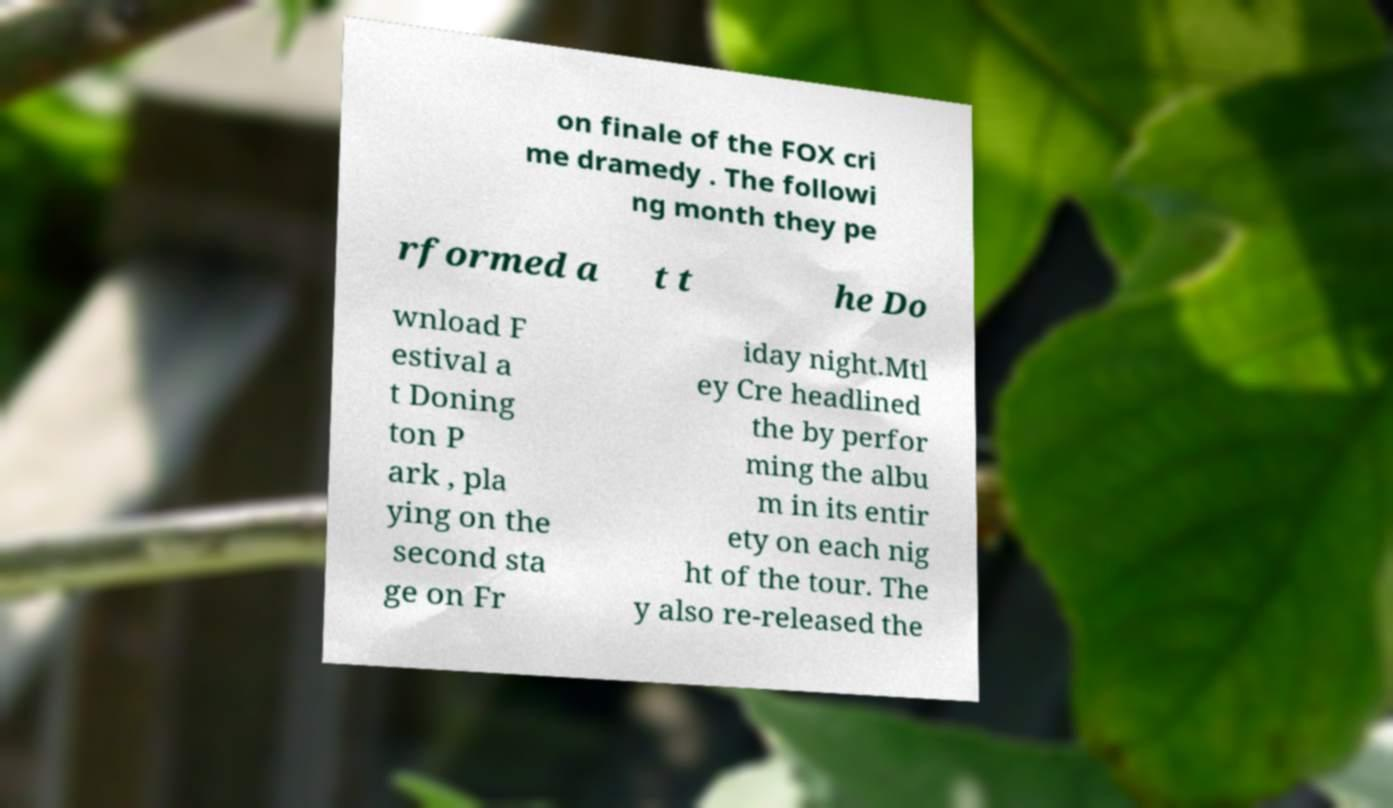I need the written content from this picture converted into text. Can you do that? on finale of the FOX cri me dramedy . The followi ng month they pe rformed a t t he Do wnload F estival a t Doning ton P ark , pla ying on the second sta ge on Fr iday night.Mtl ey Cre headlined the by perfor ming the albu m in its entir ety on each nig ht of the tour. The y also re-released the 